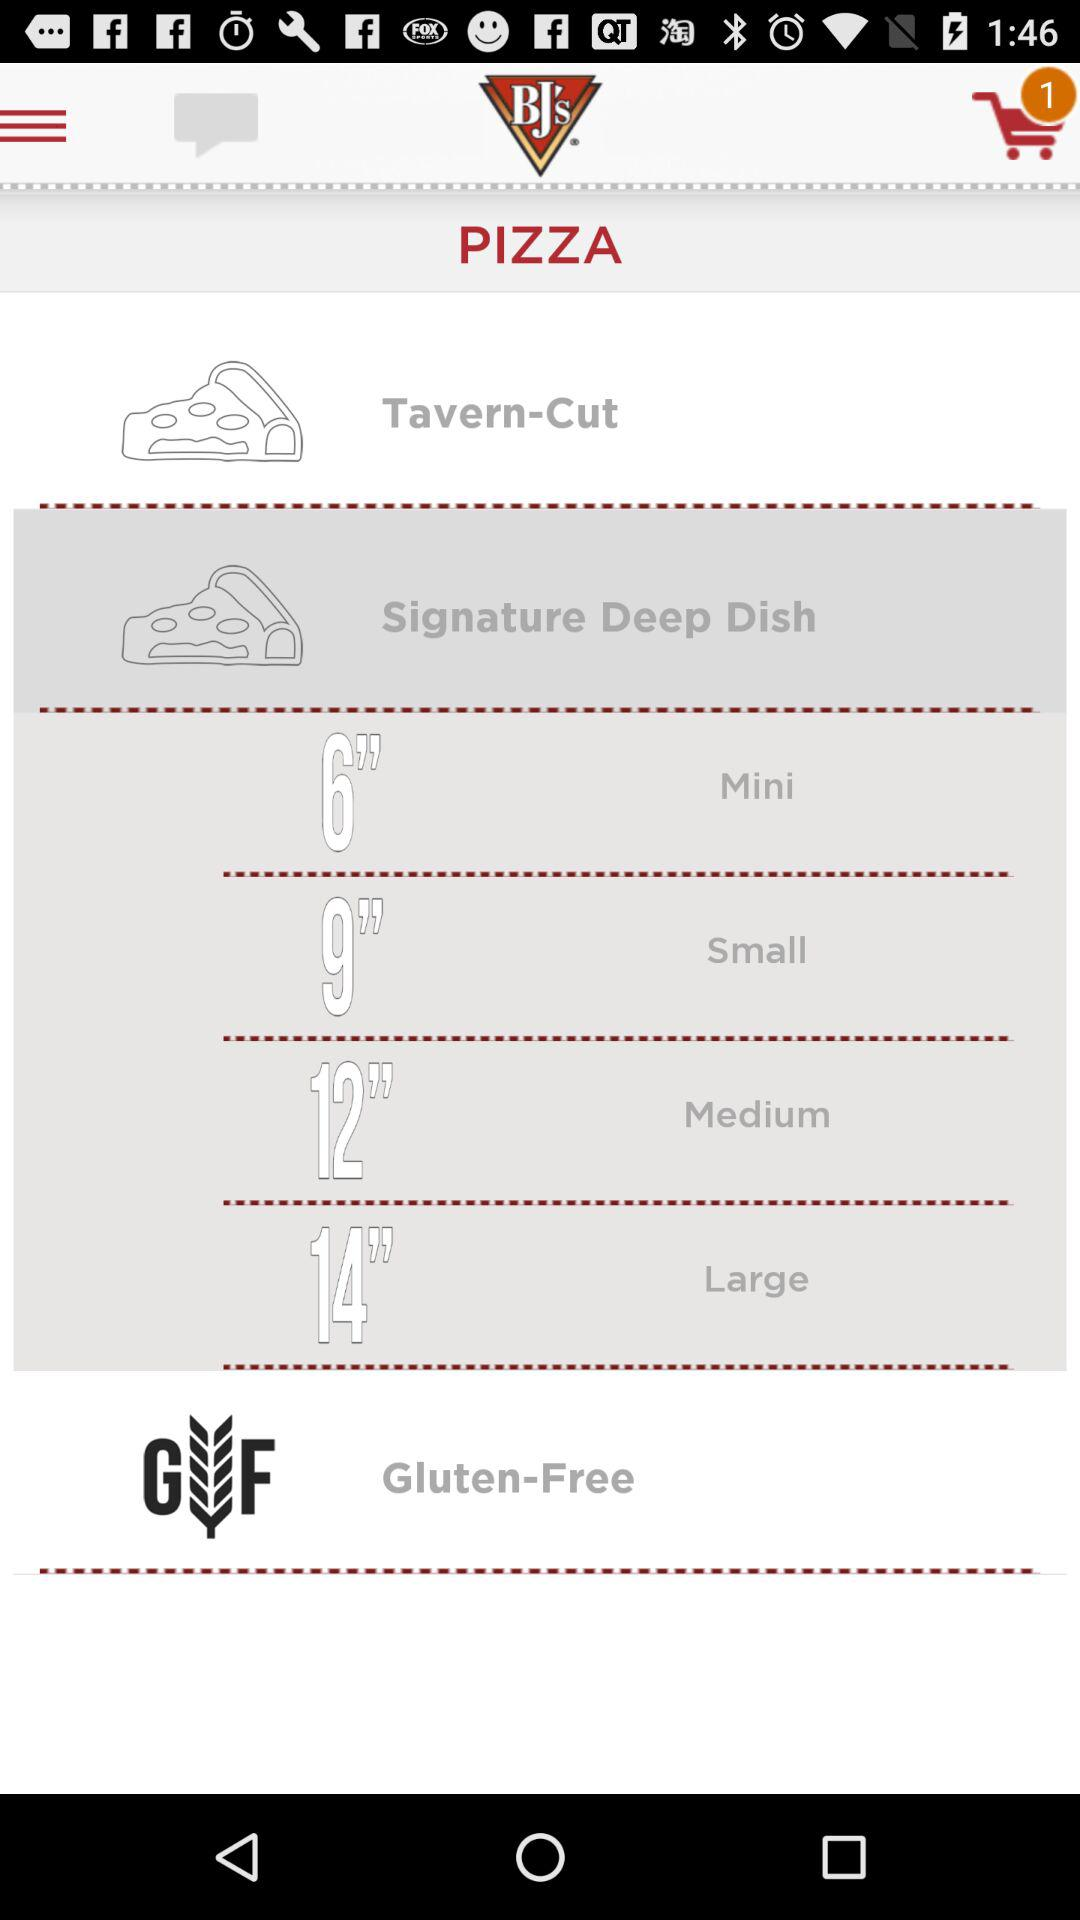What is the size of the medium signature deep dish in inches? The size of the medium signature deep dish in inches is 12. 